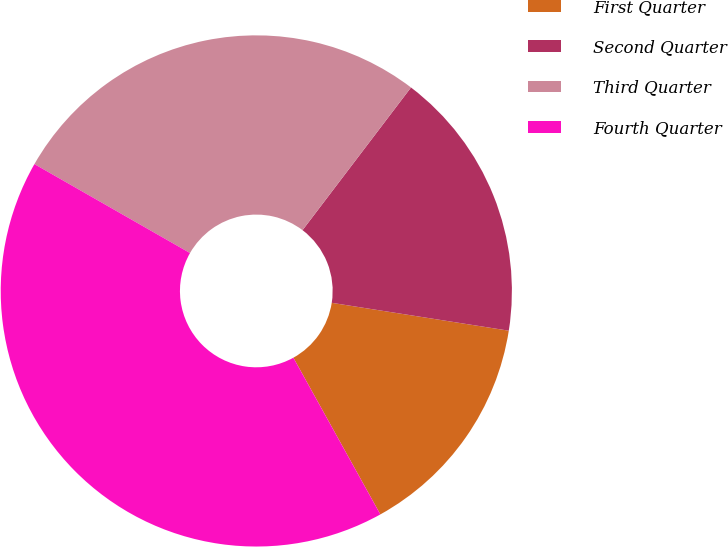<chart> <loc_0><loc_0><loc_500><loc_500><pie_chart><fcel>First Quarter<fcel>Second Quarter<fcel>Third Quarter<fcel>Fourth Quarter<nl><fcel>14.45%<fcel>17.14%<fcel>27.08%<fcel>41.33%<nl></chart> 